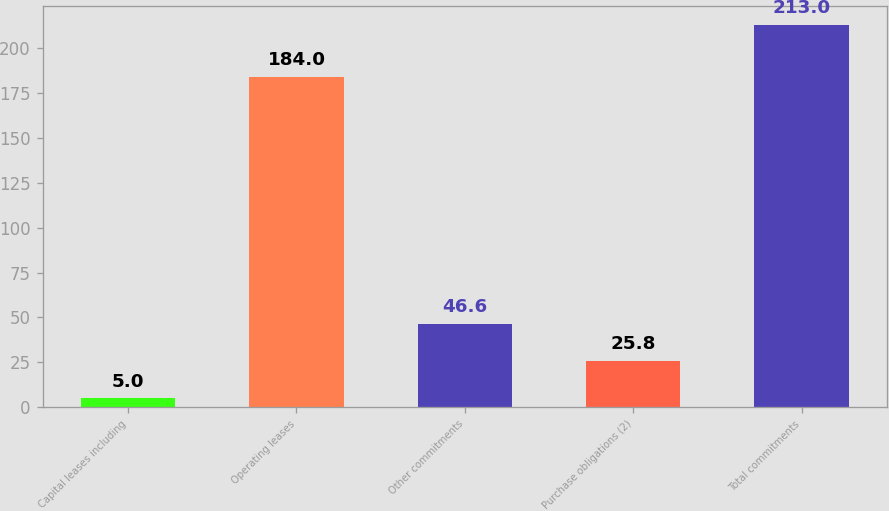Convert chart to OTSL. <chart><loc_0><loc_0><loc_500><loc_500><bar_chart><fcel>Capital leases including<fcel>Operating leases<fcel>Other commitments<fcel>Purchase obligations (2)<fcel>Total commitments<nl><fcel>5<fcel>184<fcel>46.6<fcel>25.8<fcel>213<nl></chart> 